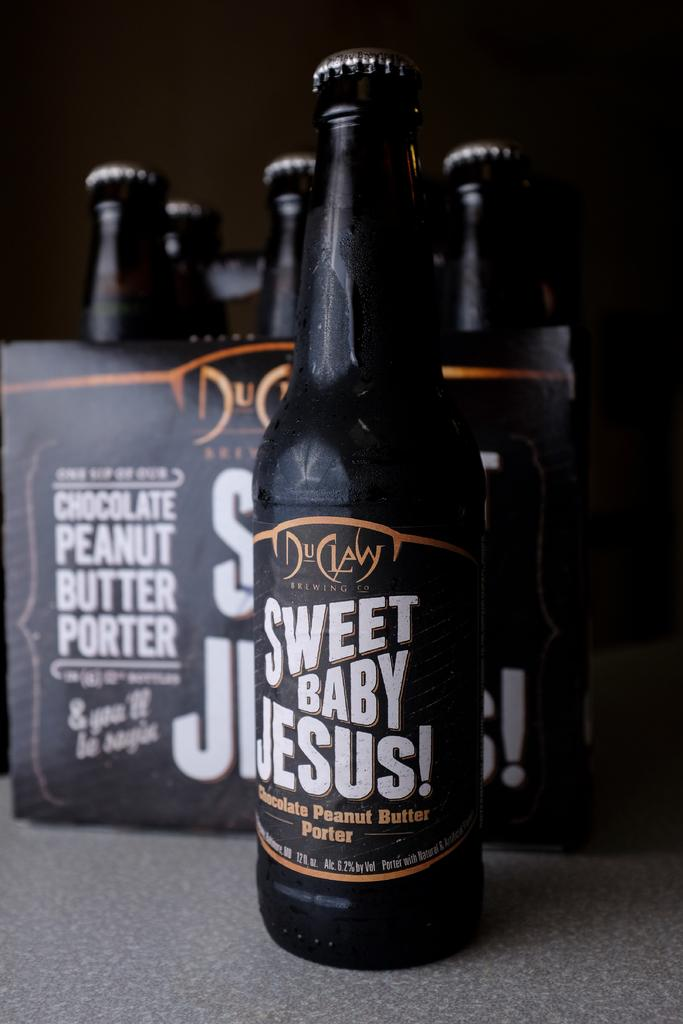<image>
Render a clear and concise summary of the photo. A bottle of DuClaw Sweet Baby Jesus brand chocolate peanut butter porter. 